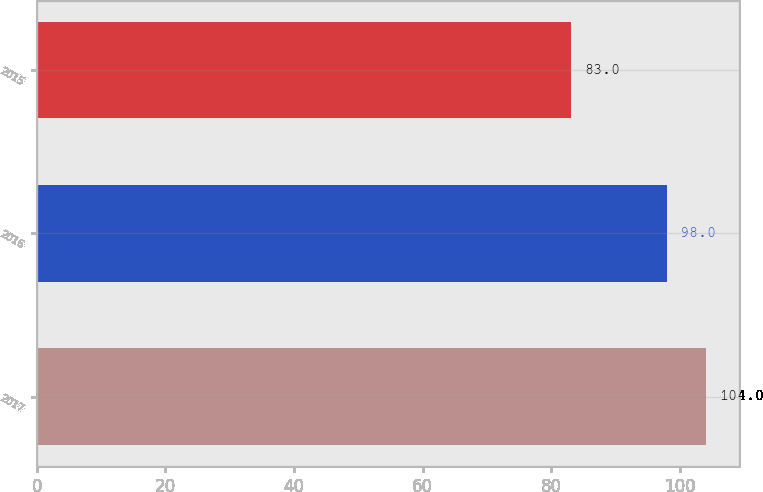Convert chart. <chart><loc_0><loc_0><loc_500><loc_500><bar_chart><fcel>2017<fcel>2016<fcel>2015<nl><fcel>104<fcel>98<fcel>83<nl></chart> 